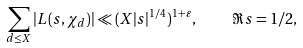<formula> <loc_0><loc_0><loc_500><loc_500>\sum _ { d \leq X } | L ( s , \chi _ { d } ) | \ll ( X | s | ^ { 1 / 4 } ) ^ { 1 + \varepsilon } , \quad \Re s = 1 / 2 ,</formula> 